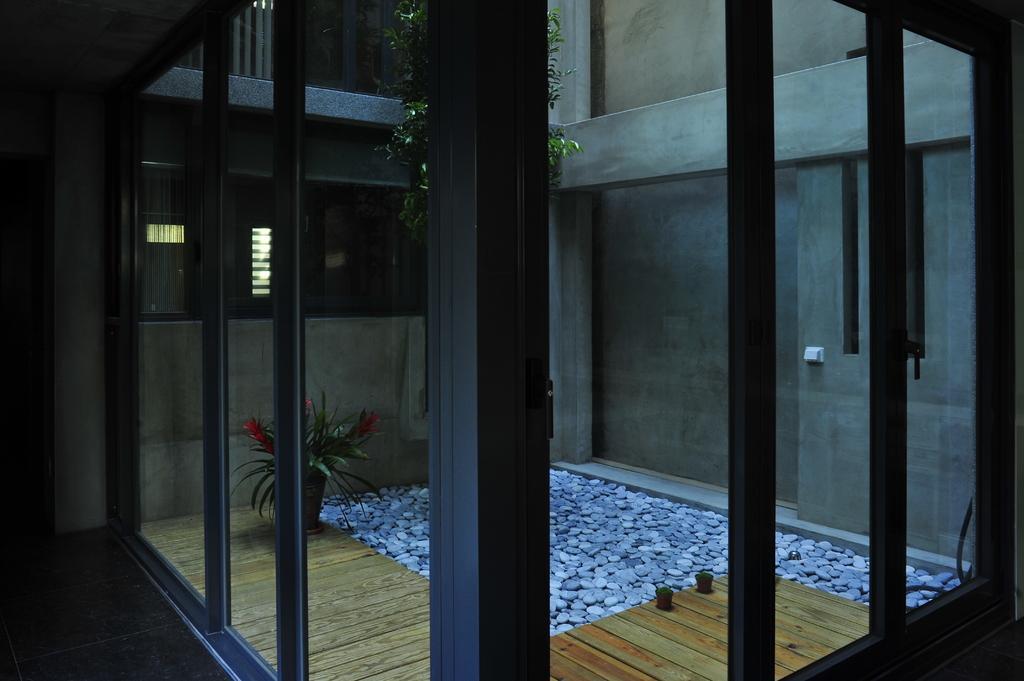In one or two sentences, can you explain what this image depicts? It is the glass wall, there are stones in this, on the left side there is a plant pot. 